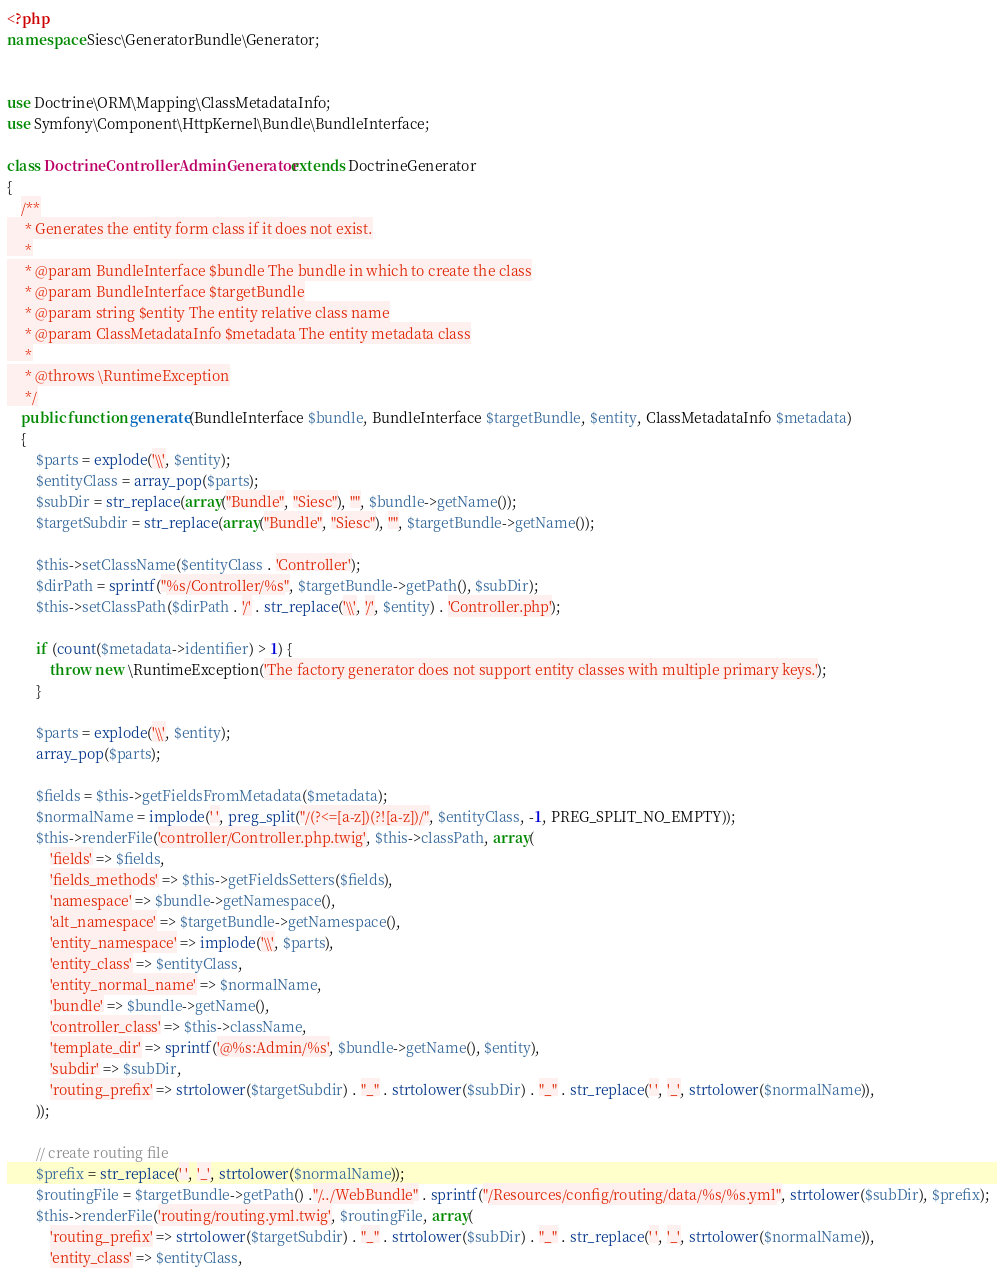Convert code to text. <code><loc_0><loc_0><loc_500><loc_500><_PHP_><?php
namespace Siesc\GeneratorBundle\Generator;


use Doctrine\ORM\Mapping\ClassMetadataInfo;
use Symfony\Component\HttpKernel\Bundle\BundleInterface;

class DoctrineControllerAdminGenerator extends DoctrineGenerator
{
    /**
     * Generates the entity form class if it does not exist.
     *
     * @param BundleInterface $bundle The bundle in which to create the class
     * @param BundleInterface $targetBundle
     * @param string $entity The entity relative class name
     * @param ClassMetadataInfo $metadata The entity metadata class
     *
     * @throws \RuntimeException
     */
    public function generate(BundleInterface $bundle, BundleInterface $targetBundle, $entity, ClassMetadataInfo $metadata)
    {
        $parts = explode('\\', $entity);
        $entityClass = array_pop($parts);
        $subDir = str_replace(array("Bundle", "Siesc"), "", $bundle->getName());
        $targetSubdir = str_replace(array("Bundle", "Siesc"), "", $targetBundle->getName());

        $this->setClassName($entityClass . 'Controller');
        $dirPath = sprintf("%s/Controller/%s", $targetBundle->getPath(), $subDir);
        $this->setClassPath($dirPath . '/' . str_replace('\\', '/', $entity) . 'Controller.php');

        if (count($metadata->identifier) > 1) {
            throw new \RuntimeException('The factory generator does not support entity classes with multiple primary keys.');
        }

        $parts = explode('\\', $entity);
        array_pop($parts);

        $fields = $this->getFieldsFromMetadata($metadata);
        $normalName = implode(' ', preg_split("/(?<=[a-z])(?![a-z])/", $entityClass, -1, PREG_SPLIT_NO_EMPTY));
        $this->renderFile('controller/Controller.php.twig', $this->classPath, array(
            'fields' => $fields,
            'fields_methods' => $this->getFieldsSetters($fields),
            'namespace' => $bundle->getNamespace(),
            'alt_namespace' => $targetBundle->getNamespace(),
            'entity_namespace' => implode('\\', $parts),
            'entity_class' => $entityClass,
            'entity_normal_name' => $normalName,
            'bundle' => $bundle->getName(),
            'controller_class' => $this->className,
            'template_dir' => sprintf('@%s:Admin/%s', $bundle->getName(), $entity),
            'subdir' => $subDir,
            'routing_prefix' => strtolower($targetSubdir) . "_" . strtolower($subDir) . "_" . str_replace(' ', '_', strtolower($normalName)),
        ));

        // create routing file
        $prefix = str_replace(' ', '_', strtolower($normalName));
        $routingFile = $targetBundle->getPath() ."/../WebBundle" . sprintf("/Resources/config/routing/data/%s/%s.yml", strtolower($subDir), $prefix);
        $this->renderFile('routing/routing.yml.twig', $routingFile, array(
            'routing_prefix' => strtolower($targetSubdir) . "_" . strtolower($subDir) . "_" . str_replace(' ', '_', strtolower($normalName)),
            'entity_class' => $entityClass,</code> 